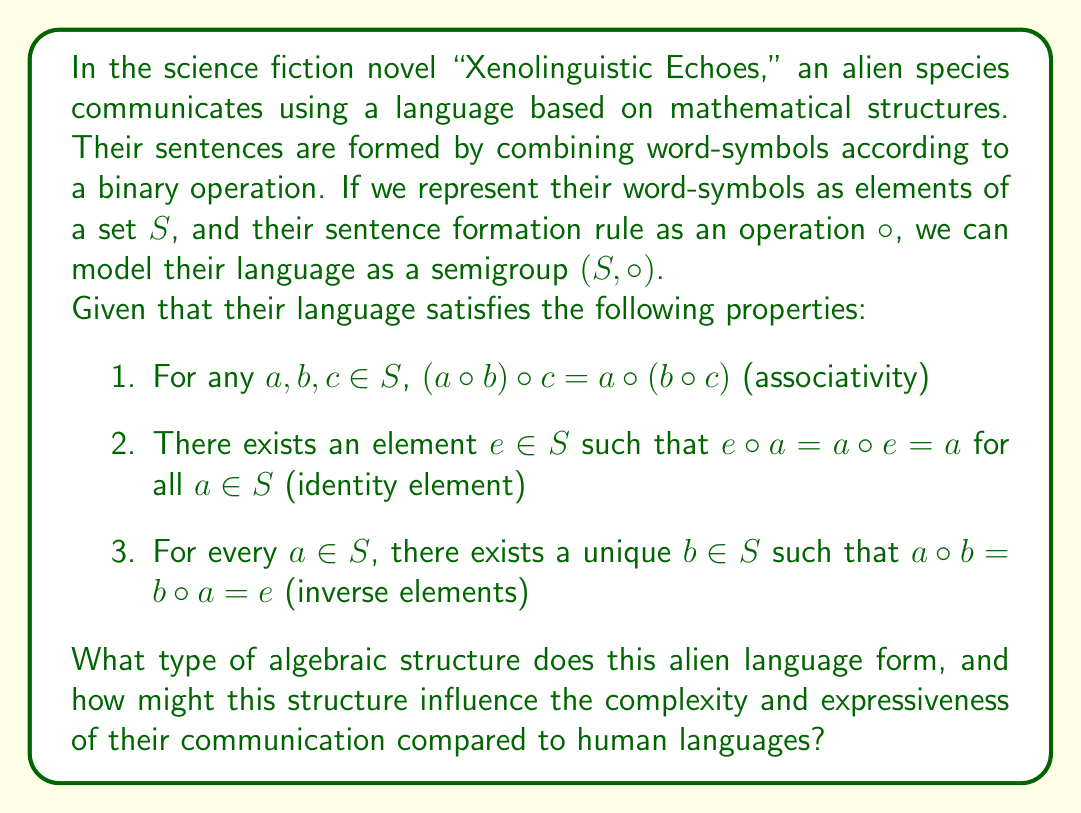Could you help me with this problem? To determine the algebraic structure of this alien language, let's analyze the given properties:

1. Associativity: The operation $\circ$ is associative, which is a fundamental property of semigroups.

2. Identity element: The existence of an identity element $e$ is not a property of semigroups in general, but it is a property of monoids, which are semigroups with an identity element.

3. Inverse elements: The existence of unique inverse elements for every element in the set is not a property of semigroups or monoids, but it is a defining property of groups.

Given that the alien language satisfies all three properties, we can conclude that it forms a group structure. Specifically, $(S, \circ)$ is a group because:
- It is closed under the operation $\circ$ (implied by the semigroup structure)
- The operation $\circ$ is associative
- There exists an identity element $e$
- Every element has a unique inverse

The group structure of this alien language has several implications for its complexity and expressiveness compared to human languages:

1. Reversibility: Every "sentence" (element) in the language has a unique inverse, which could allow for precise negation or reversal of meaning.

2. Composition: The associative property ensures that complex sentences can be built up from simpler elements in a consistent manner, regardless of the order of composition.

3. Identity: The presence of an identity element could represent a "null" or "neutral" concept in the language.

4. Mathematical precision: The group structure imposes a rigorous mathematical framework on the language, potentially allowing for more precise and unambiguous communication compared to human languages.

5. Symmetry: The group structure implies a high degree of symmetry in the language, which could lead to elegant and efficient ways of expressing complex ideas.

6. Abstraction: The abstract nature of group theory could allow the aliens to express and manipulate abstract concepts more easily than in human languages.

7. Computational aspects: The group structure might facilitate easier processing and analysis of the language by computers or the alien equivalent.

This mathematical basis for the language could result in a communication system that is more precise and logically structured than human languages, but potentially less flexible or nuanced in expressing subjective or emotional content.
Answer: The alien language forms a group structure. This algebraic structure could lead to a more mathematically precise and logically consistent form of communication compared to human languages, potentially enhancing the aliens' ability to express abstract and complex ideas efficiently, but possibly at the cost of reduced flexibility in conveying subjective or emotional content. 